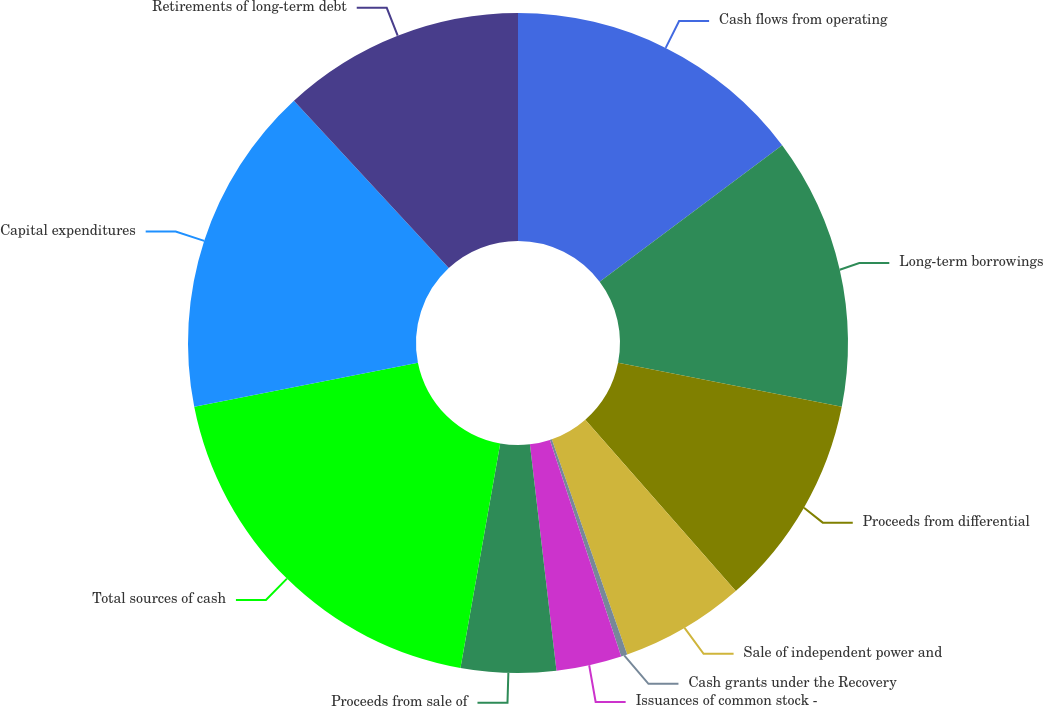Convert chart. <chart><loc_0><loc_0><loc_500><loc_500><pie_chart><fcel>Cash flows from operating<fcel>Long-term borrowings<fcel>Proceeds from differential<fcel>Sale of independent power and<fcel>Cash grants under the Recovery<fcel>Issuances of common stock -<fcel>Proceeds from sale of<fcel>Total sources of cash<fcel>Capital expenditures<fcel>Retirements of long-term debt<nl><fcel>14.77%<fcel>13.33%<fcel>10.43%<fcel>6.1%<fcel>0.31%<fcel>3.2%<fcel>4.65%<fcel>19.11%<fcel>16.22%<fcel>11.88%<nl></chart> 